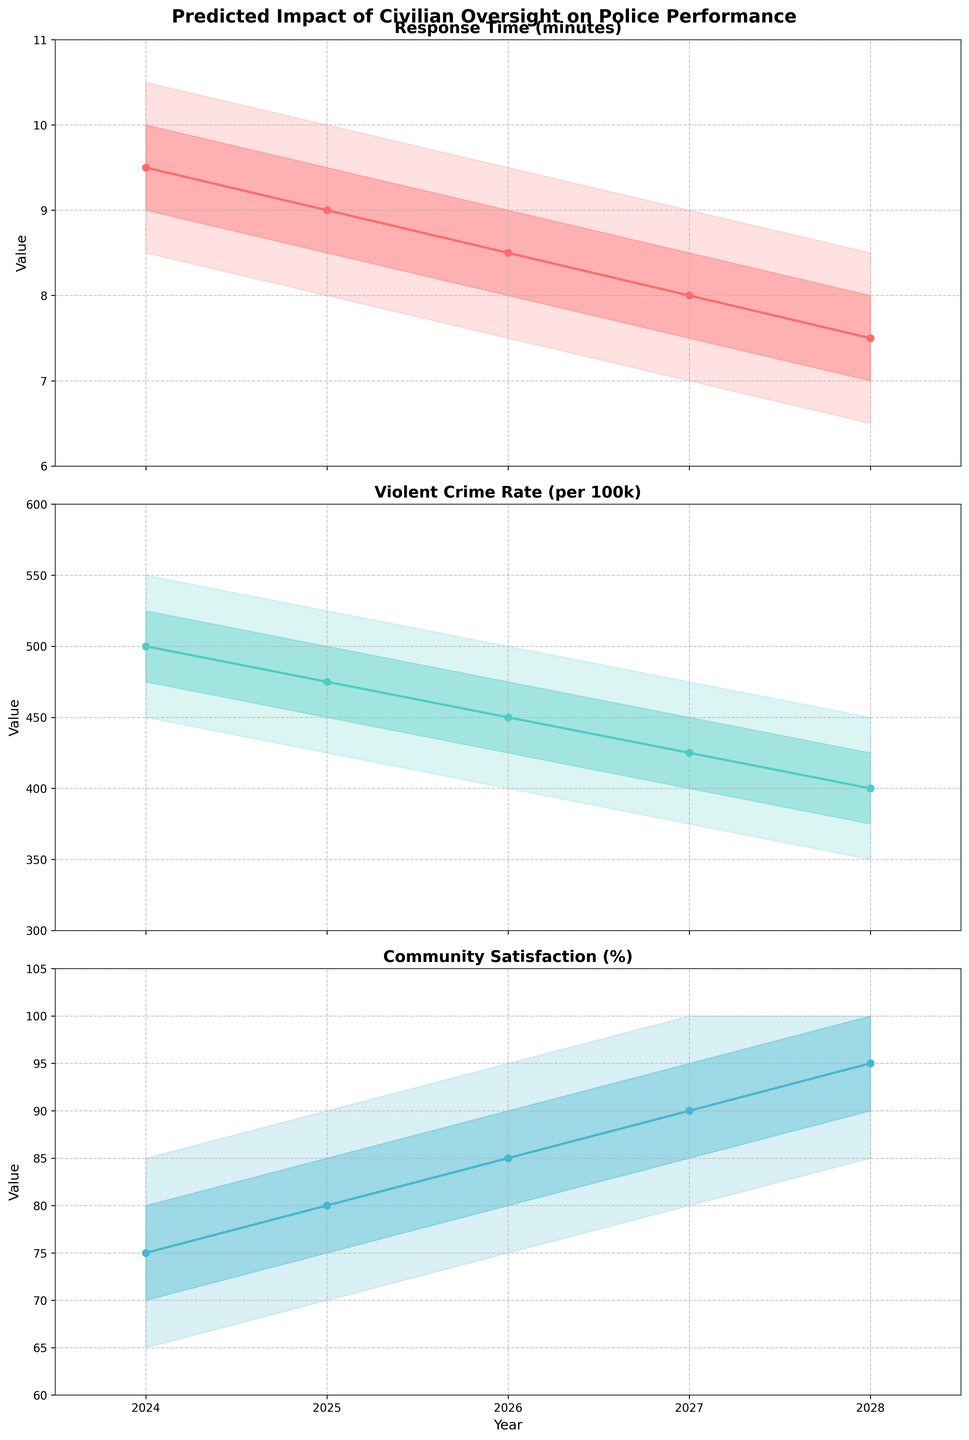What is the title of the figure? The title is found at the top of the figure and describes the main subject of the chart.
Answer: Predicted Impact of Civilian Oversight on Police Performance What color is used for the Response Time (minutes) metric? The color for each metric is visually distinct. From the figure, Response Time (minutes) uses a red-like hue.
Answer: Red What is the mid-value for Response Time (minutes) in 2026? Look at the Response Time (minutes) section of the figure, find the data point for 2026, and locate the Mid-value line.
Answer: 8.5 minutes By how much is the Violent Crime Rate (per 100k) predicted to reduce from 2024 to 2028 at the Mid-value? Identify the Mid-values for Violent Crime Rate (per 100k) in 2024 and 2028, then subtract the 2028 value from the 2024 value.
Answer: 100 (500 - 400) Which metric shows the most improvement over time at the Mid-value? Compare the Mid-values of each metric from 2024 to 2028. The metric with the largest positive change indicates the greatest improvement.
Answer: Community Satisfaction (%) How does the predicted Response Time (minutes) in 2024 compare to 2028 based on the High-values? Find the High-values for Response Time (minutes) in 2024 and 2028, and compare them to determine which year has a higher predicted time.
Answer: Higher in 2024 (10.5 vs. 8.5) Which year has the highest predicted Mid-value for Community Satisfaction (%)? Look at the Community Satisfaction (%) section for the year with the highest predicted Mid-value.
Answer: 2028 What is the range of predicted Violent Crime Rate (per 100k) in 2025? The range can be found by subtracting the Low-value from the High-value for Violent Crime Rate (per 100k) in 2025.
Answer: 100 (525 - 425) What is the average of the Mid-values for Response Time (minutes) from 2024 to 2028? Sum the Mid-values for each year and divide by the number of years (5).
Answer: 8.1 ((9.5 + 9.0 + 8.5 + 8.0 + 7.5) / 5) Between 2024 and 2028, which metric shows the greatest decrease in the High-values? For each metric, subtract the High-value in 2028 from the High-value in 2024, then compare the differences to see which is the largest.
Answer: Response Time (minutes) 